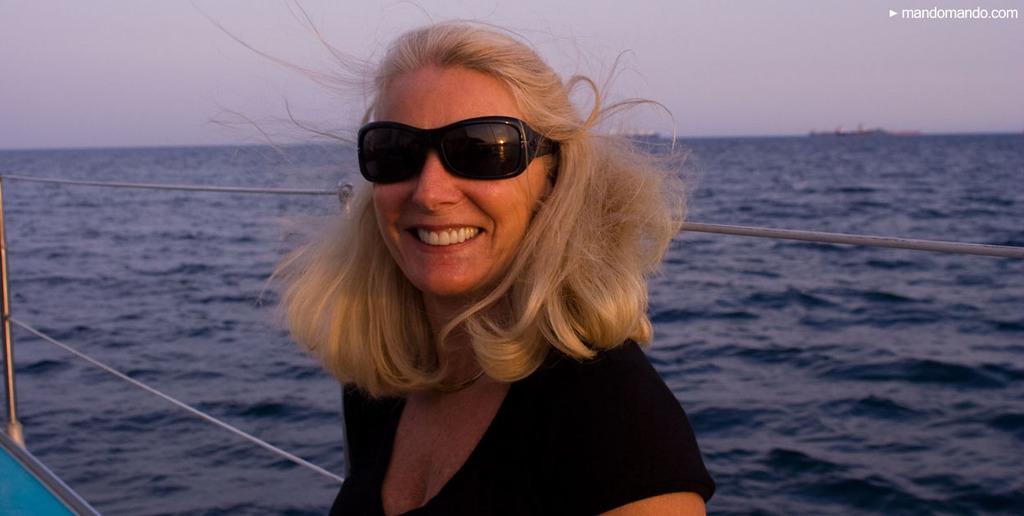Can you describe this image briefly? In this image there is a person on the boat , which is on the water, and in the background there are boats on the water and there is sky and a watermark on the image. 